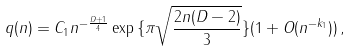Convert formula to latex. <formula><loc_0><loc_0><loc_500><loc_500>q ( n ) = C _ { 1 } n ^ { - \frac { D + 1 } { 4 } } \exp { \{ \pi \sqrt { \frac { 2 n ( D - 2 ) } { 3 } } \} } ( 1 + O ( n ^ { - k _ { 1 } } ) ) \, ,</formula> 